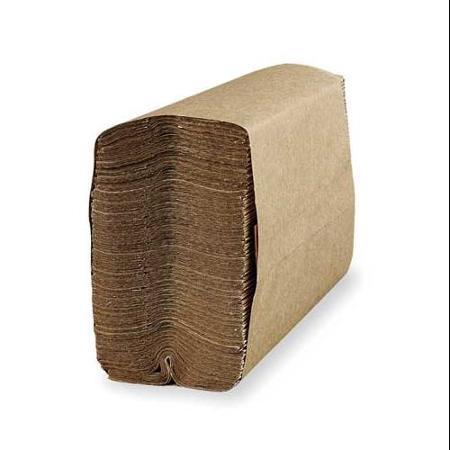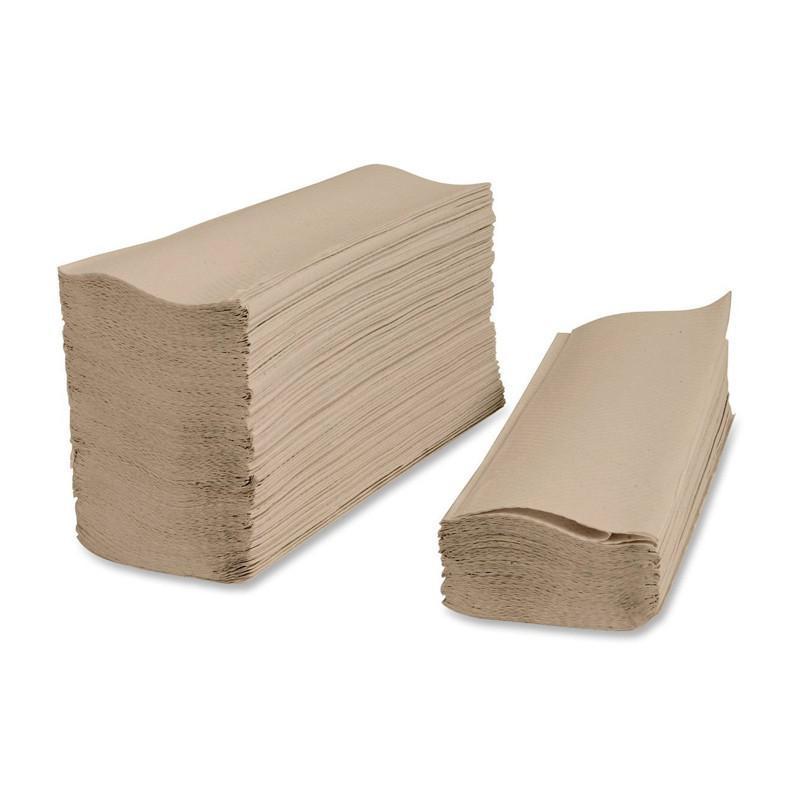The first image is the image on the left, the second image is the image on the right. Given the left and right images, does the statement "the right pic has a stack of tissues without holder" hold true? Answer yes or no. Yes. The first image is the image on the left, the second image is the image on the right. Given the left and right images, does the statement "The image to the right features brown squares of paper towels." hold true? Answer yes or no. Yes. 